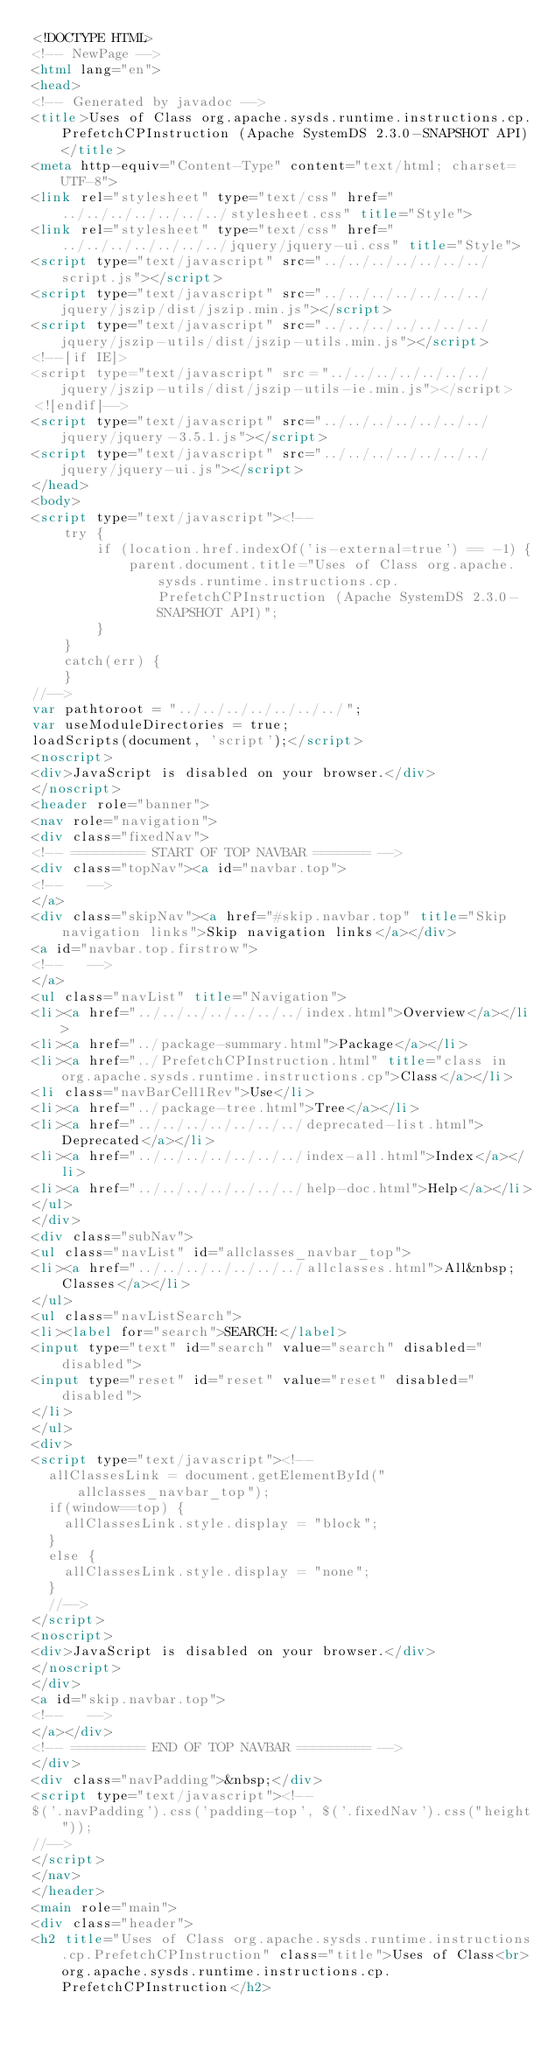Convert code to text. <code><loc_0><loc_0><loc_500><loc_500><_HTML_><!DOCTYPE HTML>
<!-- NewPage -->
<html lang="en">
<head>
<!-- Generated by javadoc -->
<title>Uses of Class org.apache.sysds.runtime.instructions.cp.PrefetchCPInstruction (Apache SystemDS 2.3.0-SNAPSHOT API)</title>
<meta http-equiv="Content-Type" content="text/html; charset=UTF-8">
<link rel="stylesheet" type="text/css" href="../../../../../../../stylesheet.css" title="Style">
<link rel="stylesheet" type="text/css" href="../../../../../../../jquery/jquery-ui.css" title="Style">
<script type="text/javascript" src="../../../../../../../script.js"></script>
<script type="text/javascript" src="../../../../../../../jquery/jszip/dist/jszip.min.js"></script>
<script type="text/javascript" src="../../../../../../../jquery/jszip-utils/dist/jszip-utils.min.js"></script>
<!--[if IE]>
<script type="text/javascript" src="../../../../../../../jquery/jszip-utils/dist/jszip-utils-ie.min.js"></script>
<![endif]-->
<script type="text/javascript" src="../../../../../../../jquery/jquery-3.5.1.js"></script>
<script type="text/javascript" src="../../../../../../../jquery/jquery-ui.js"></script>
</head>
<body>
<script type="text/javascript"><!--
    try {
        if (location.href.indexOf('is-external=true') == -1) {
            parent.document.title="Uses of Class org.apache.sysds.runtime.instructions.cp.PrefetchCPInstruction (Apache SystemDS 2.3.0-SNAPSHOT API)";
        }
    }
    catch(err) {
    }
//-->
var pathtoroot = "../../../../../../../";
var useModuleDirectories = true;
loadScripts(document, 'script');</script>
<noscript>
<div>JavaScript is disabled on your browser.</div>
</noscript>
<header role="banner">
<nav role="navigation">
<div class="fixedNav">
<!-- ========= START OF TOP NAVBAR ======= -->
<div class="topNav"><a id="navbar.top">
<!--   -->
</a>
<div class="skipNav"><a href="#skip.navbar.top" title="Skip navigation links">Skip navigation links</a></div>
<a id="navbar.top.firstrow">
<!--   -->
</a>
<ul class="navList" title="Navigation">
<li><a href="../../../../../../../index.html">Overview</a></li>
<li><a href="../package-summary.html">Package</a></li>
<li><a href="../PrefetchCPInstruction.html" title="class in org.apache.sysds.runtime.instructions.cp">Class</a></li>
<li class="navBarCell1Rev">Use</li>
<li><a href="../package-tree.html">Tree</a></li>
<li><a href="../../../../../../../deprecated-list.html">Deprecated</a></li>
<li><a href="../../../../../../../index-all.html">Index</a></li>
<li><a href="../../../../../../../help-doc.html">Help</a></li>
</ul>
</div>
<div class="subNav">
<ul class="navList" id="allclasses_navbar_top">
<li><a href="../../../../../../../allclasses.html">All&nbsp;Classes</a></li>
</ul>
<ul class="navListSearch">
<li><label for="search">SEARCH:</label>
<input type="text" id="search" value="search" disabled="disabled">
<input type="reset" id="reset" value="reset" disabled="disabled">
</li>
</ul>
<div>
<script type="text/javascript"><!--
  allClassesLink = document.getElementById("allclasses_navbar_top");
  if(window==top) {
    allClassesLink.style.display = "block";
  }
  else {
    allClassesLink.style.display = "none";
  }
  //-->
</script>
<noscript>
<div>JavaScript is disabled on your browser.</div>
</noscript>
</div>
<a id="skip.navbar.top">
<!--   -->
</a></div>
<!-- ========= END OF TOP NAVBAR ========= -->
</div>
<div class="navPadding">&nbsp;</div>
<script type="text/javascript"><!--
$('.navPadding').css('padding-top', $('.fixedNav').css("height"));
//-->
</script>
</nav>
</header>
<main role="main">
<div class="header">
<h2 title="Uses of Class org.apache.sysds.runtime.instructions.cp.PrefetchCPInstruction" class="title">Uses of Class<br>org.apache.sysds.runtime.instructions.cp.PrefetchCPInstruction</h2></code> 